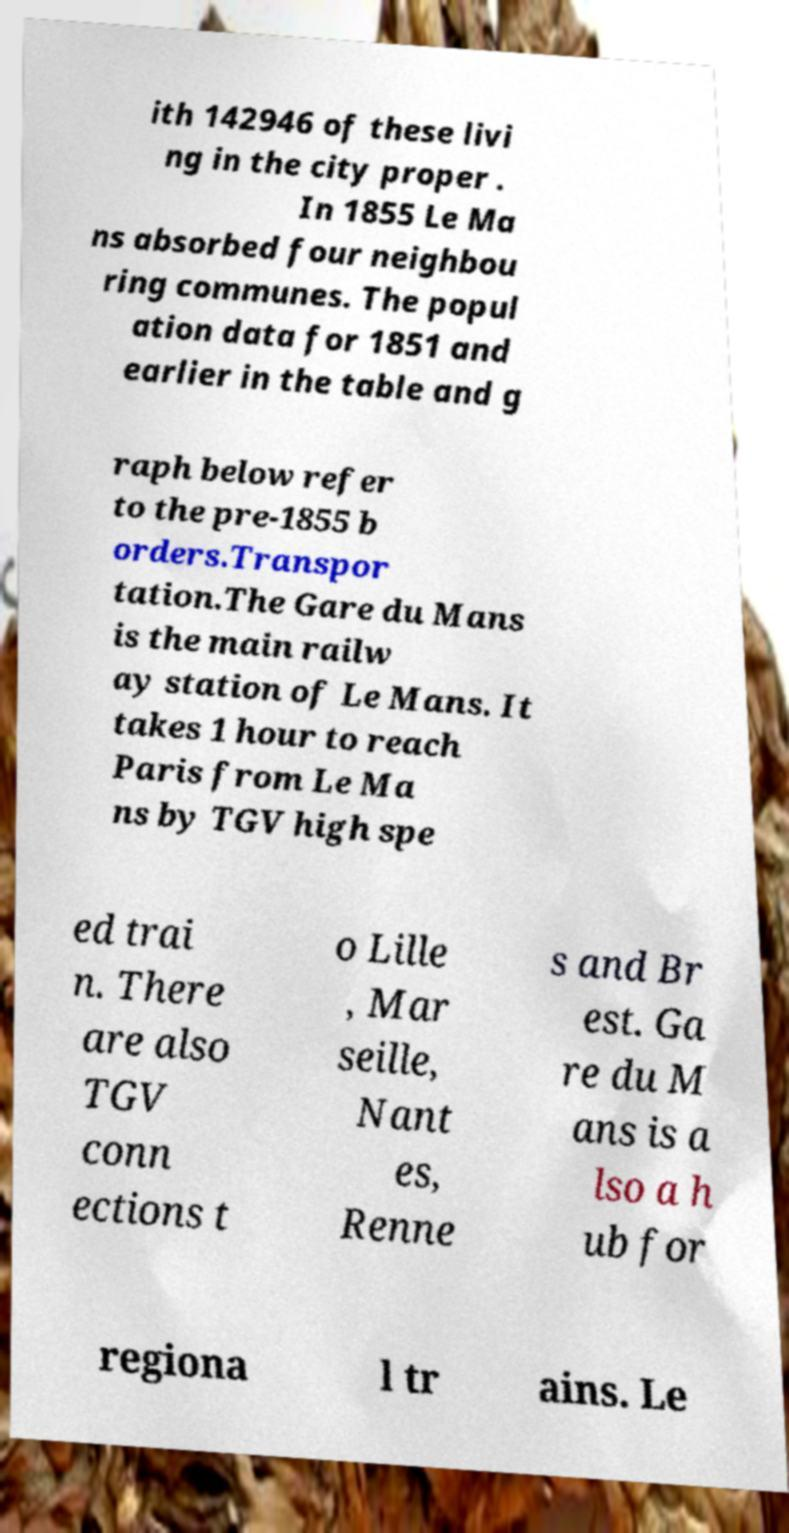Can you read and provide the text displayed in the image?This photo seems to have some interesting text. Can you extract and type it out for me? ith 142946 of these livi ng in the city proper . In 1855 Le Ma ns absorbed four neighbou ring communes. The popul ation data for 1851 and earlier in the table and g raph below refer to the pre-1855 b orders.Transpor tation.The Gare du Mans is the main railw ay station of Le Mans. It takes 1 hour to reach Paris from Le Ma ns by TGV high spe ed trai n. There are also TGV conn ections t o Lille , Mar seille, Nant es, Renne s and Br est. Ga re du M ans is a lso a h ub for regiona l tr ains. Le 